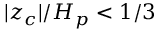Convert formula to latex. <formula><loc_0><loc_0><loc_500><loc_500>| z _ { c } | / H _ { p } < 1 / 3</formula> 